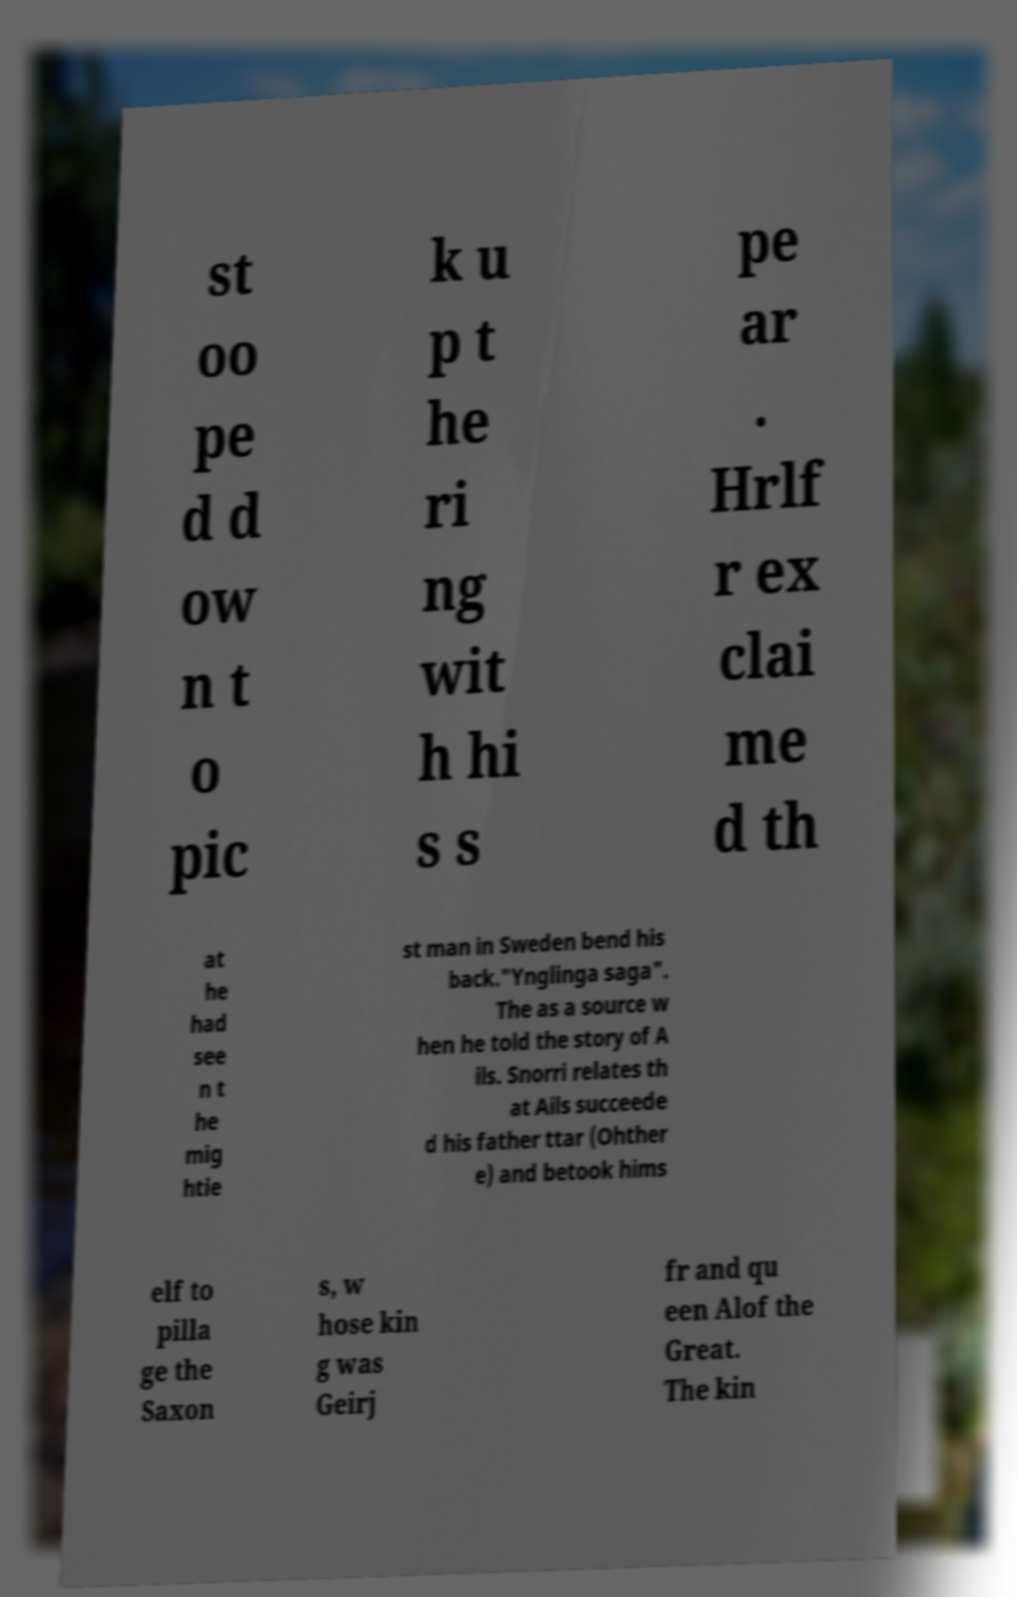Please read and relay the text visible in this image. What does it say? st oo pe d d ow n t o pic k u p t he ri ng wit h hi s s pe ar . Hrlf r ex clai me d th at he had see n t he mig htie st man in Sweden bend his back."Ynglinga saga". The as a source w hen he told the story of A ils. Snorri relates th at Ails succeede d his father ttar (Ohther e) and betook hims elf to pilla ge the Saxon s, w hose kin g was Geirj fr and qu een Alof the Great. The kin 